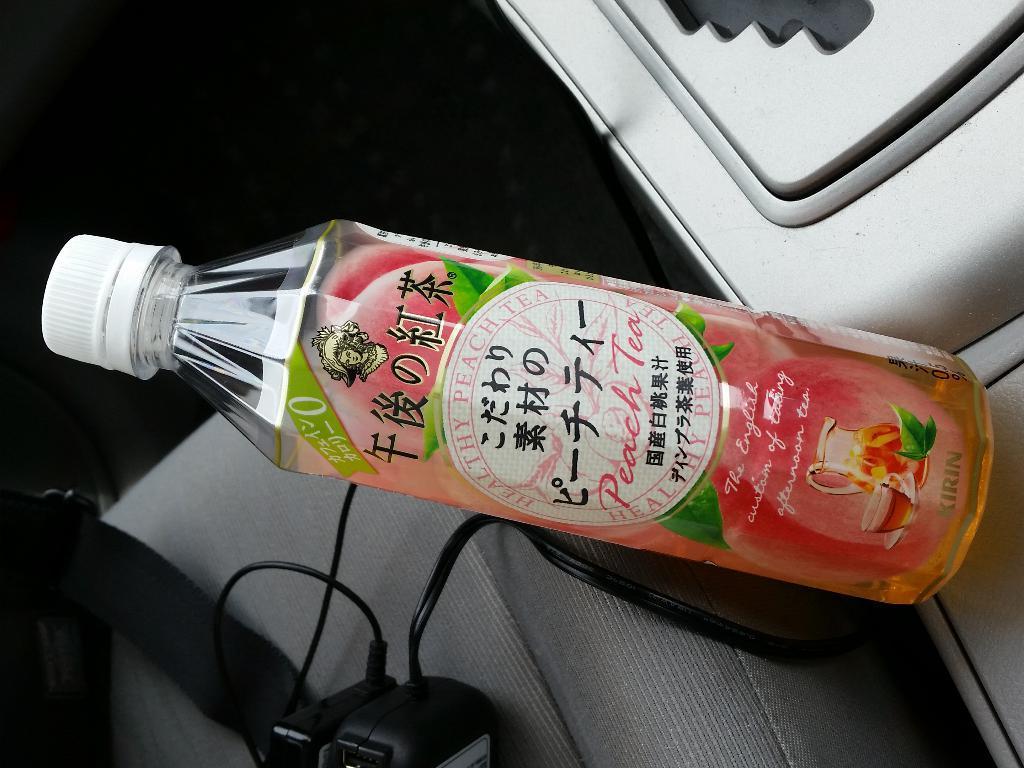Describe this image in one or two sentences. This is the picture of a bottle covered with a sticker. The bottle is on a chair, on the chair there are cables and some items. 